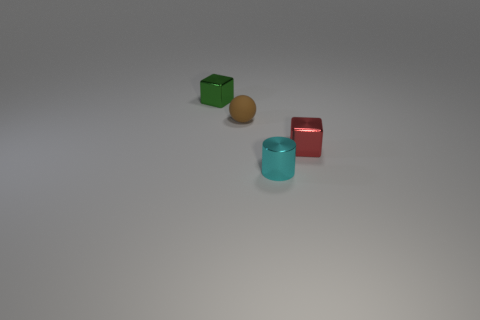Add 2 tiny shiny blocks. How many objects exist? 6 Subtract all cylinders. How many objects are left? 3 Subtract 0 brown cylinders. How many objects are left? 4 Subtract all blue metal cylinders. Subtract all small red cubes. How many objects are left? 3 Add 3 green shiny cubes. How many green shiny cubes are left? 4 Add 1 small brown metal cylinders. How many small brown metal cylinders exist? 1 